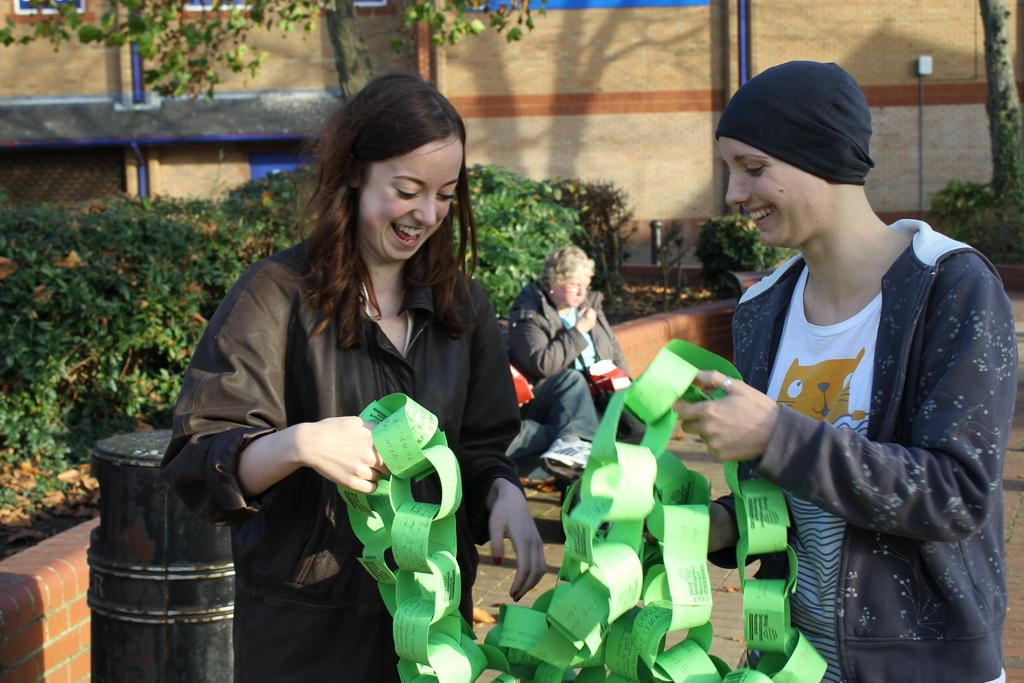How many women are present in the image? There are two women in the image. What are the women holding in the image? The women are holding papers in the image. Can you describe the position of the third woman in the image? There is a woman sitting on the backside of the image. What type of object can be seen in the image? There is a container in the image. What architectural feature is present in the image? There is a fence in the image. What type of vegetation can be seen in the image? There is a group of plants and trees in the image. What type of structure is visible in the image? There is a wall in the image. What type of icicle can be seen hanging from the woman's hair in the image? There are no icicles present in the image; it is not a cold or snowy environment. 